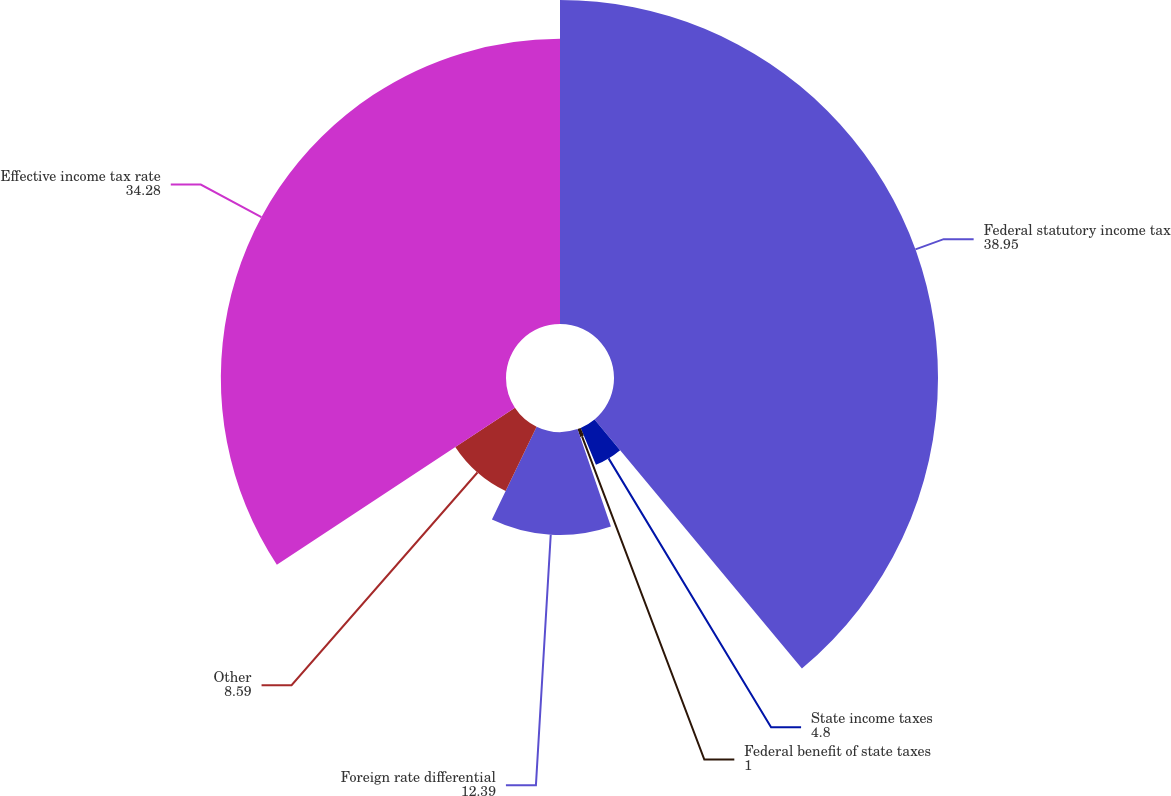Convert chart to OTSL. <chart><loc_0><loc_0><loc_500><loc_500><pie_chart><fcel>Federal statutory income tax<fcel>State income taxes<fcel>Federal benefit of state taxes<fcel>Foreign rate differential<fcel>Other<fcel>Effective income tax rate<nl><fcel>38.95%<fcel>4.8%<fcel>1.0%<fcel>12.39%<fcel>8.59%<fcel>34.28%<nl></chart> 